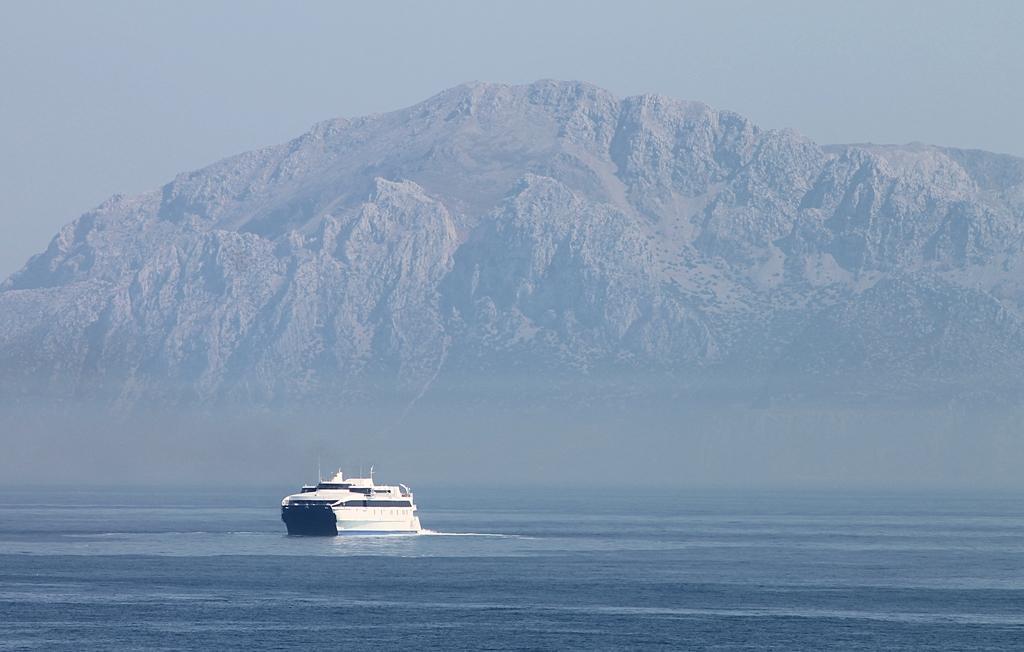Describe this image in one or two sentences. In this image I can see the ship on the water. The ship is in white color and the water are in blue color. In the background I can see the mountain and the sky. 